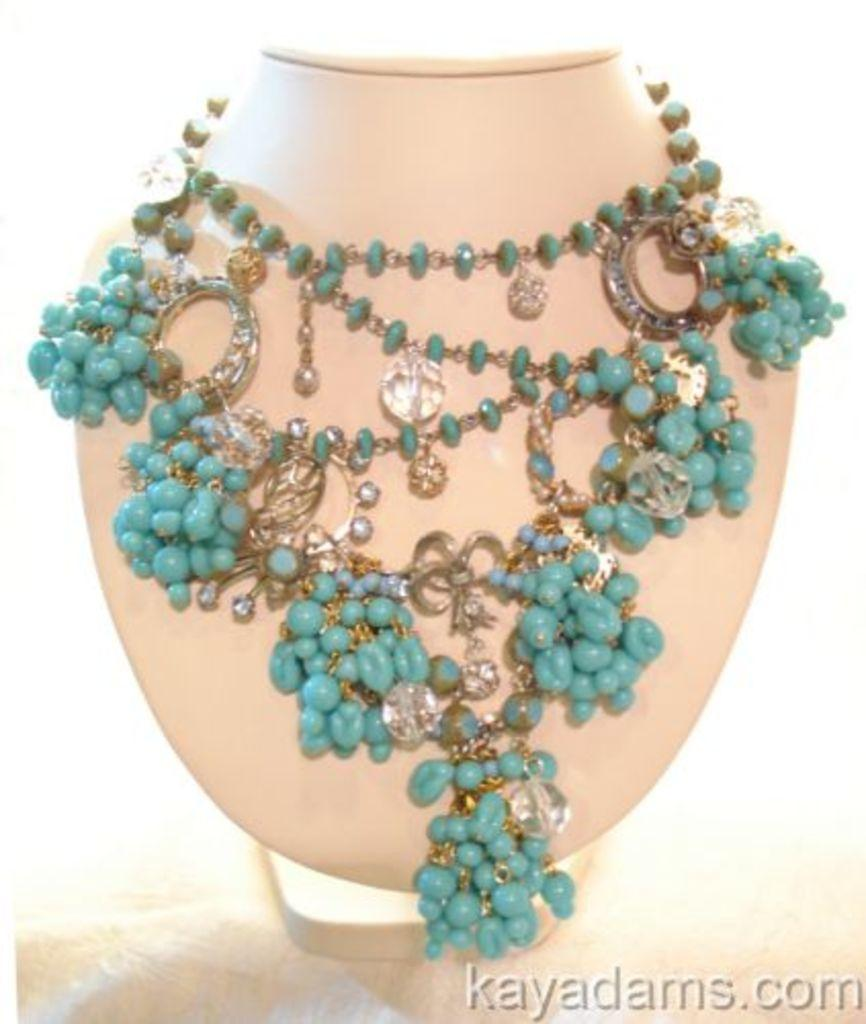What type of jewelry is visible in the image? There is a blue jewelry in the image. Where is the blue jewelry placed? The blue jewelry is placed on an object. Is there any text or writing in the image? Yes, there is writing in the right bottom corner of the image. What type of pear is sitting on the throne in the image? There is no pear or throne present in the image. 